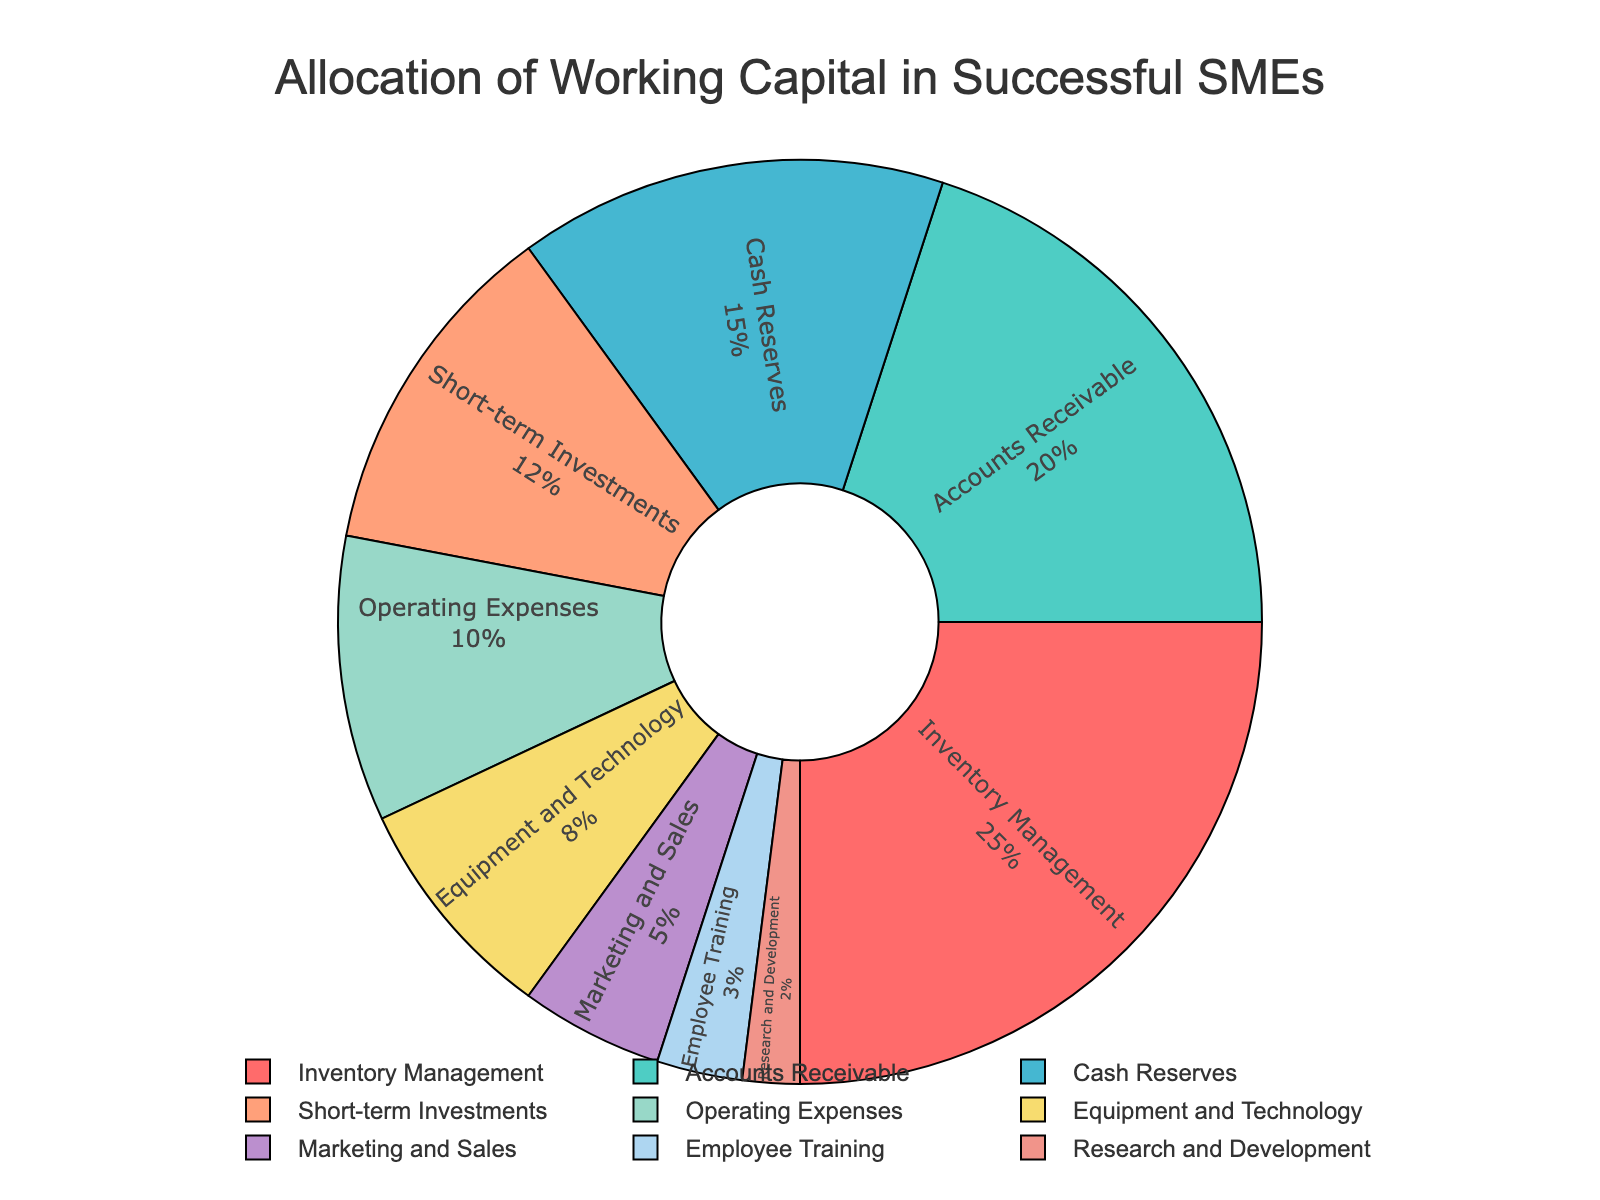What is the largest allocation category in the pie chart? The largest segment in the pie chart is marked for Inventory Management, taking up the highest percentage share. Look for the segment labeled "Inventory Management" to verify this.
Answer: Inventory Management Which category has the smallest allocation in the pie chart? The smallest segment in the pie chart is marked for Research and Development, indicating this takes up the smallest percentage share. Look for the segment labeled "Research and Development" to verify this.
Answer: Research and Development How much more is allocated to Inventory Management compared to Marketing and Sales? Inventory Management has a 25% allocation, while Marketing and Sales have a 5% allocation. Subtract the percentage for Marketing and Sales from Inventory Management: 25% - 5%.
Answer: 20% What combined percentage is allocated to Employee Training and Research and Development? Employee Training has a 3% allocation, and Research and Development has a 2% allocation. Add these two percentages together: 3% + 2%.
Answer: 5% Which category has a larger allocation: Short-term Investments or Equipment and Technology? Compare the two segments for Short-term Investments and Equipment and Technology. Short-term Investments has a 12% allocation, while Equipment and Technology has an 8% allocation.
Answer: Short-term Investments How does the percentage allocated to Accounts Receivable compare to Cash Reserves? Accounts Receivable has a 20% allocation while Cash Reserves has a 15% allocation. Accounts Receivable's allocation is 5% higher than Cash Reserves.
Answer: Accounts Receivable is 5% higher Is the allocation for Operating Expenses greater than for Equipment and Technology? Compare the two segments for Operating Expenses and Equipment and Technology. Operating Expenses have a 10% allocation, while Equipment and Technology have an 8% allocation. Yes, because 10% is greater than 8%.
Answer: Yes What is the difference in allocation percentage between Short-term Investments and Marketing and Sales? Short-term Investments has a 12% allocation and Marketing and Sales have a 5% allocation. Subtract Marketing and Sales from Short-term Investments: 12% - 5%.
Answer: 7% What are the top three categories in terms of allocation percentage? By referring to the segments, the top three categories in terms of percentage are Inventory Management (25%), Accounts Receivable (20%), and Cash Reserves (15%).
Answer: Inventory Management, Accounts Receivable, Cash Reserves How much total percentage is allocated to categories related to investments (Short-term Investments, R&D)? Short-term Investments has a 12% allocation and Research and Development has a 2% allocation. Add these two percentages together: 12% + 2%.
Answer: 14% 